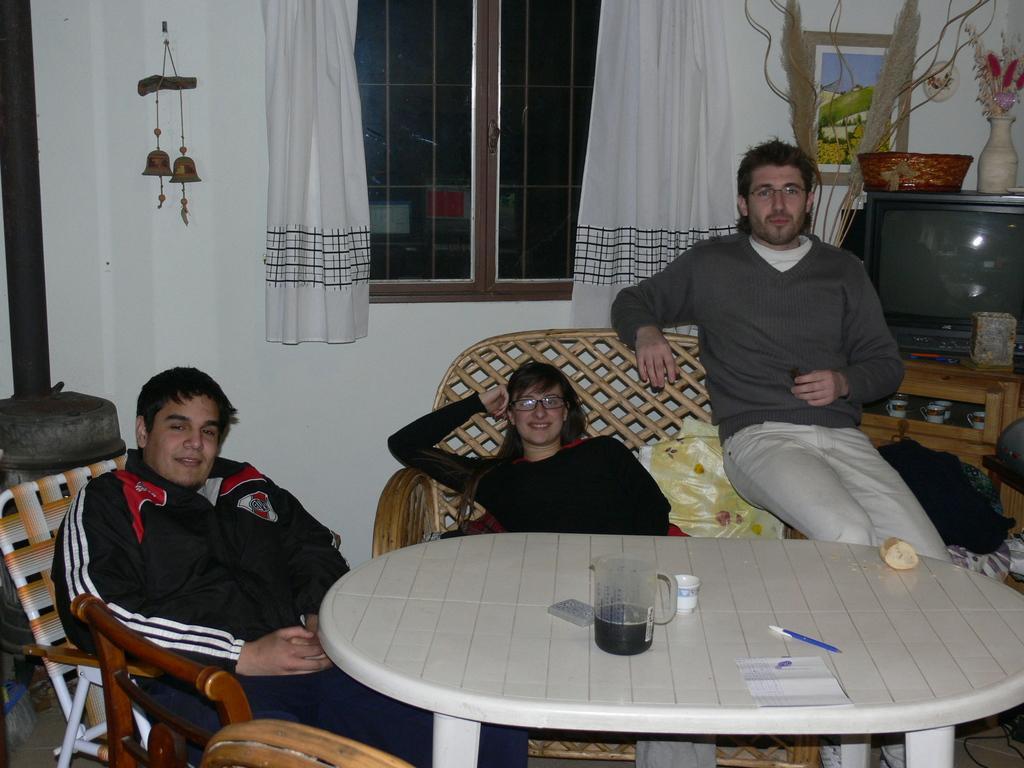Can you describe this image briefly? Here we can see 3 people each of them is sitting on chairs and there is a table in front of them there is a jar containing juice ,at the right side we can see a television and the center we can see a window and curtains along with it 